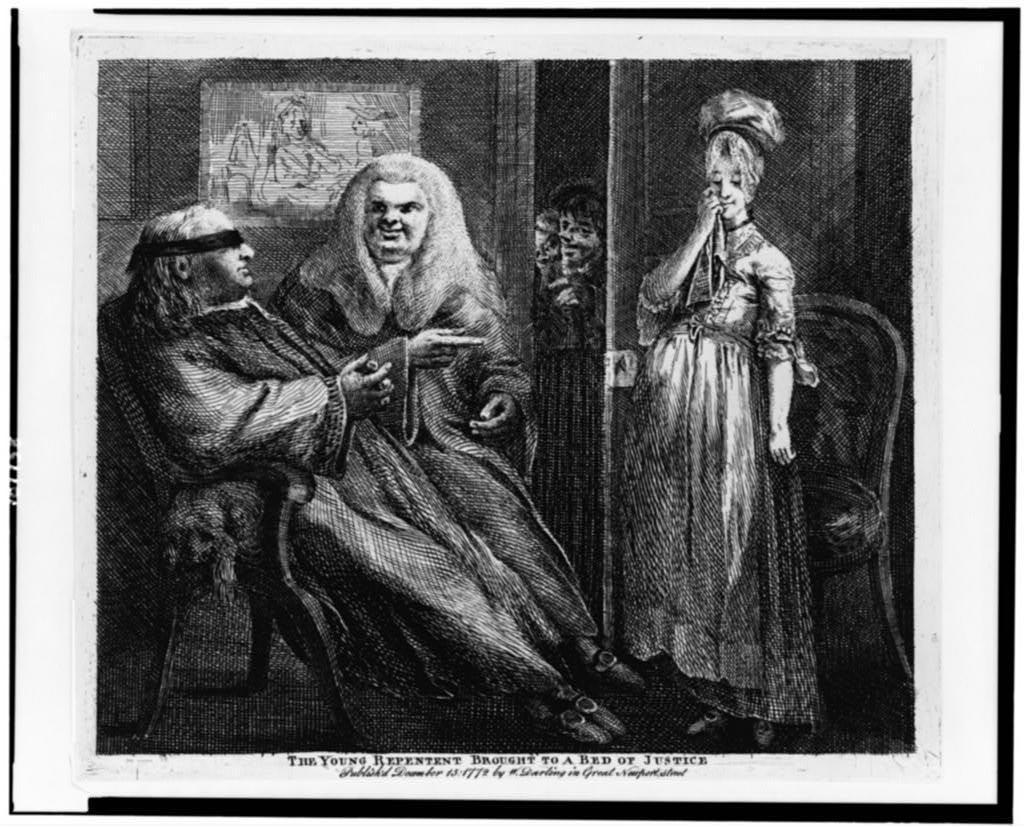Please provide a concise description of this image. In this image I can see the old black and white photograph in which I can see a person sitting on the chair, few persons standing, a chair, a wall, a photo attached to the wall and a door. I can see few other persons standing on the other side of the door. 